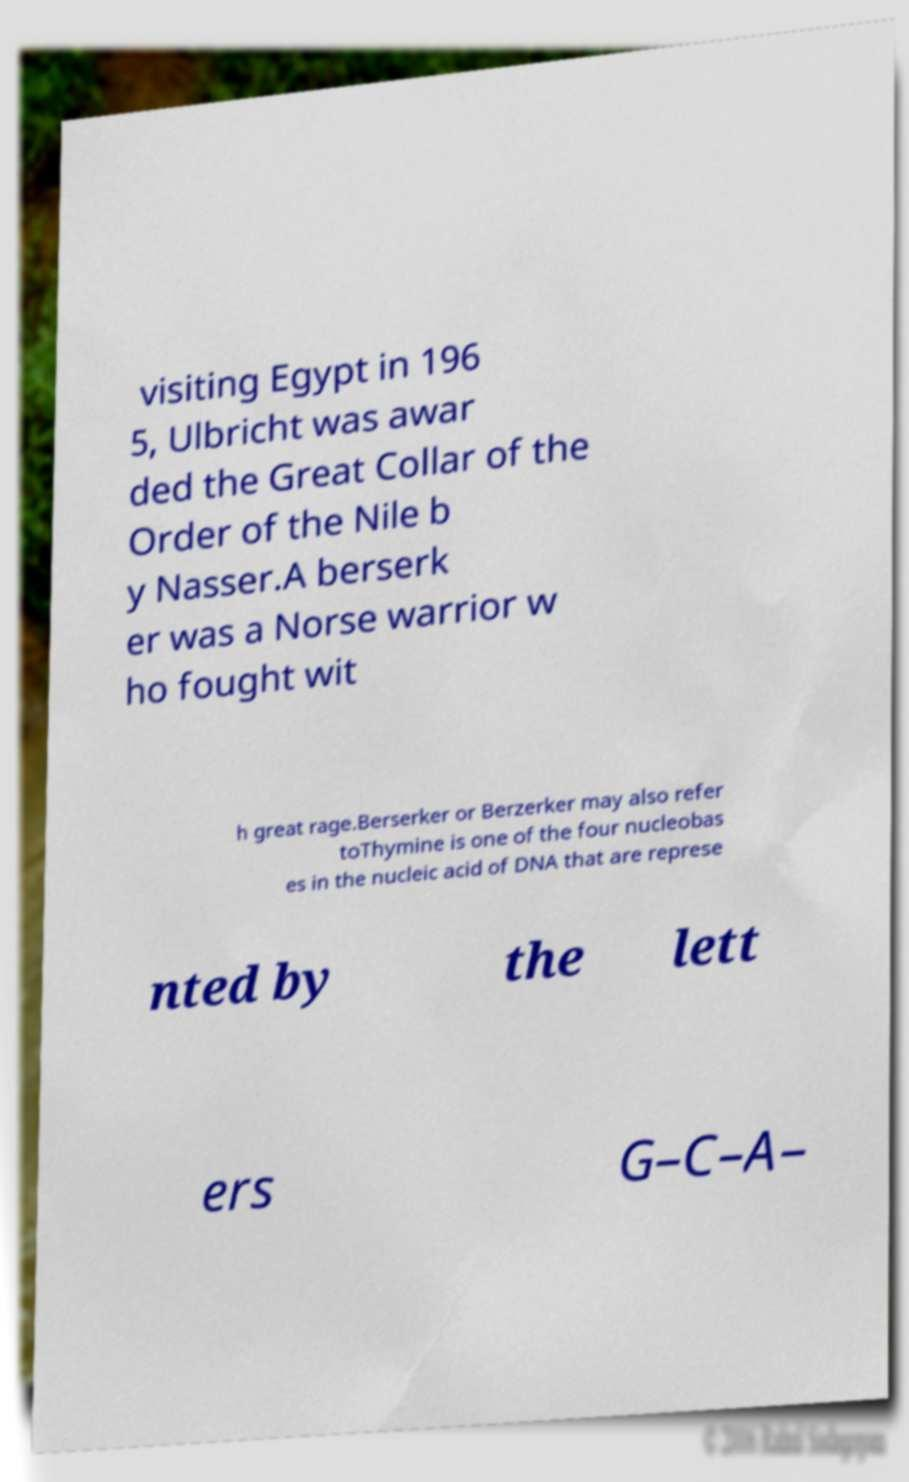Could you extract and type out the text from this image? visiting Egypt in 196 5, Ulbricht was awar ded the Great Collar of the Order of the Nile b y Nasser.A berserk er was a Norse warrior w ho fought wit h great rage.Berserker or Berzerker may also refer toThymine is one of the four nucleobas es in the nucleic acid of DNA that are represe nted by the lett ers G–C–A– 